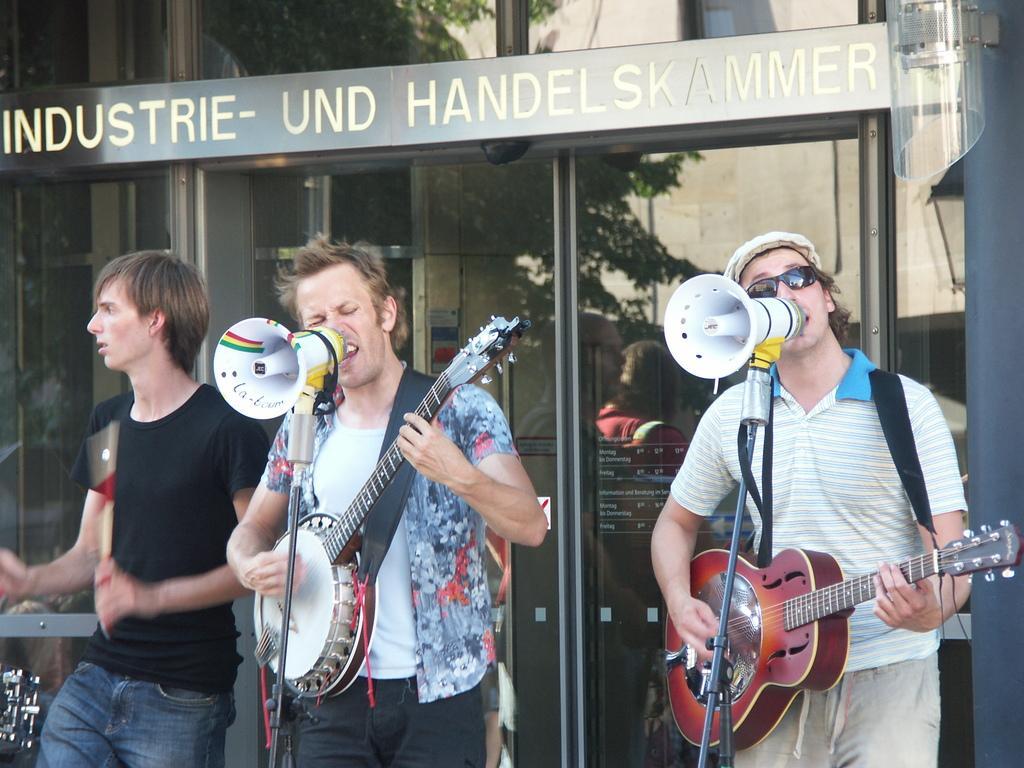Can you describe this image briefly? In this picture there are three men playing musical instruments. A man towards the left, he is wearing a black t shirt and holding sticks. In middle there is another man, he is wearing a colorful shirt and holding a guitar, in front of him there is a mike. Towards the right there is a person wearing a striped shirt and playing a guitar, in front of him there is another mike. In the background there is a building. To the building there is a board and some text printed on it. 